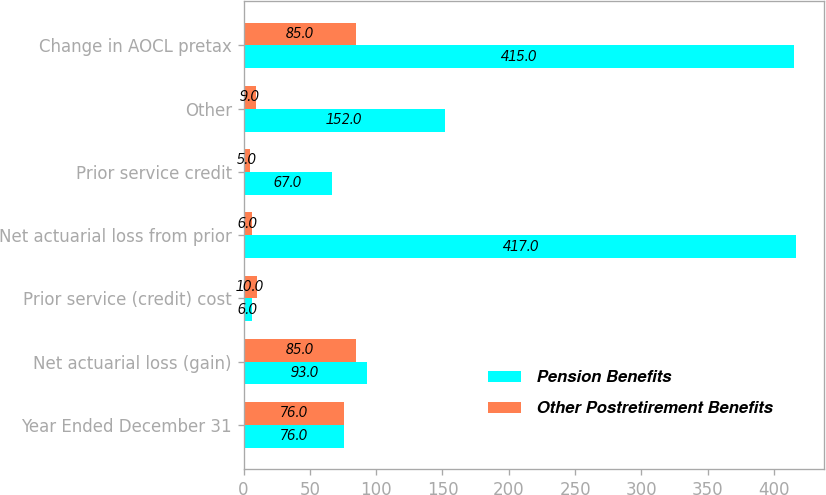Convert chart. <chart><loc_0><loc_0><loc_500><loc_500><stacked_bar_chart><ecel><fcel>Year Ended December 31<fcel>Net actuarial loss (gain)<fcel>Prior service (credit) cost<fcel>Net actuarial loss from prior<fcel>Prior service credit<fcel>Other<fcel>Change in AOCL pretax<nl><fcel>Pension Benefits<fcel>76<fcel>93<fcel>6<fcel>417<fcel>67<fcel>152<fcel>415<nl><fcel>Other Postretirement Benefits<fcel>76<fcel>85<fcel>10<fcel>6<fcel>5<fcel>9<fcel>85<nl></chart> 